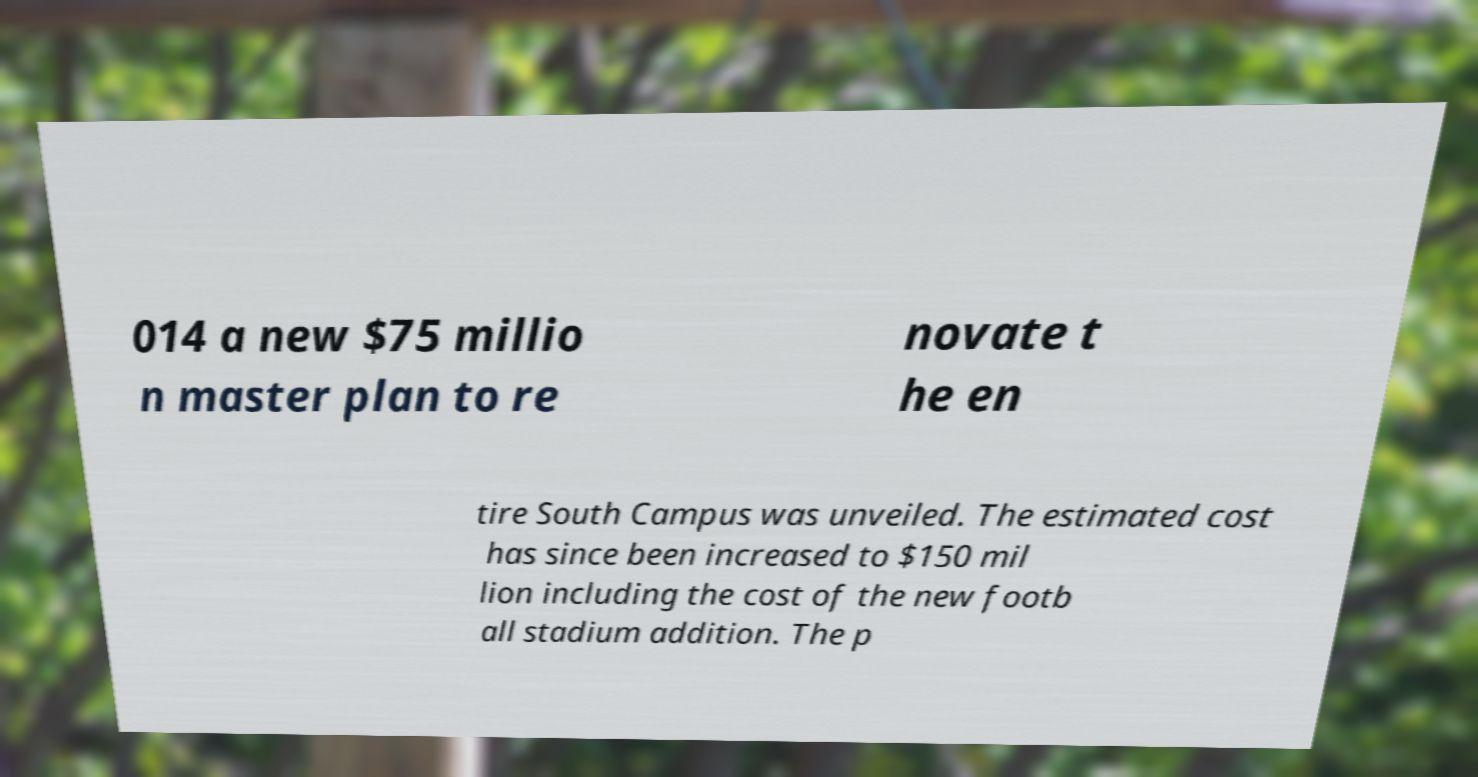Please identify and transcribe the text found in this image. 014 a new $75 millio n master plan to re novate t he en tire South Campus was unveiled. The estimated cost has since been increased to $150 mil lion including the cost of the new footb all stadium addition. The p 